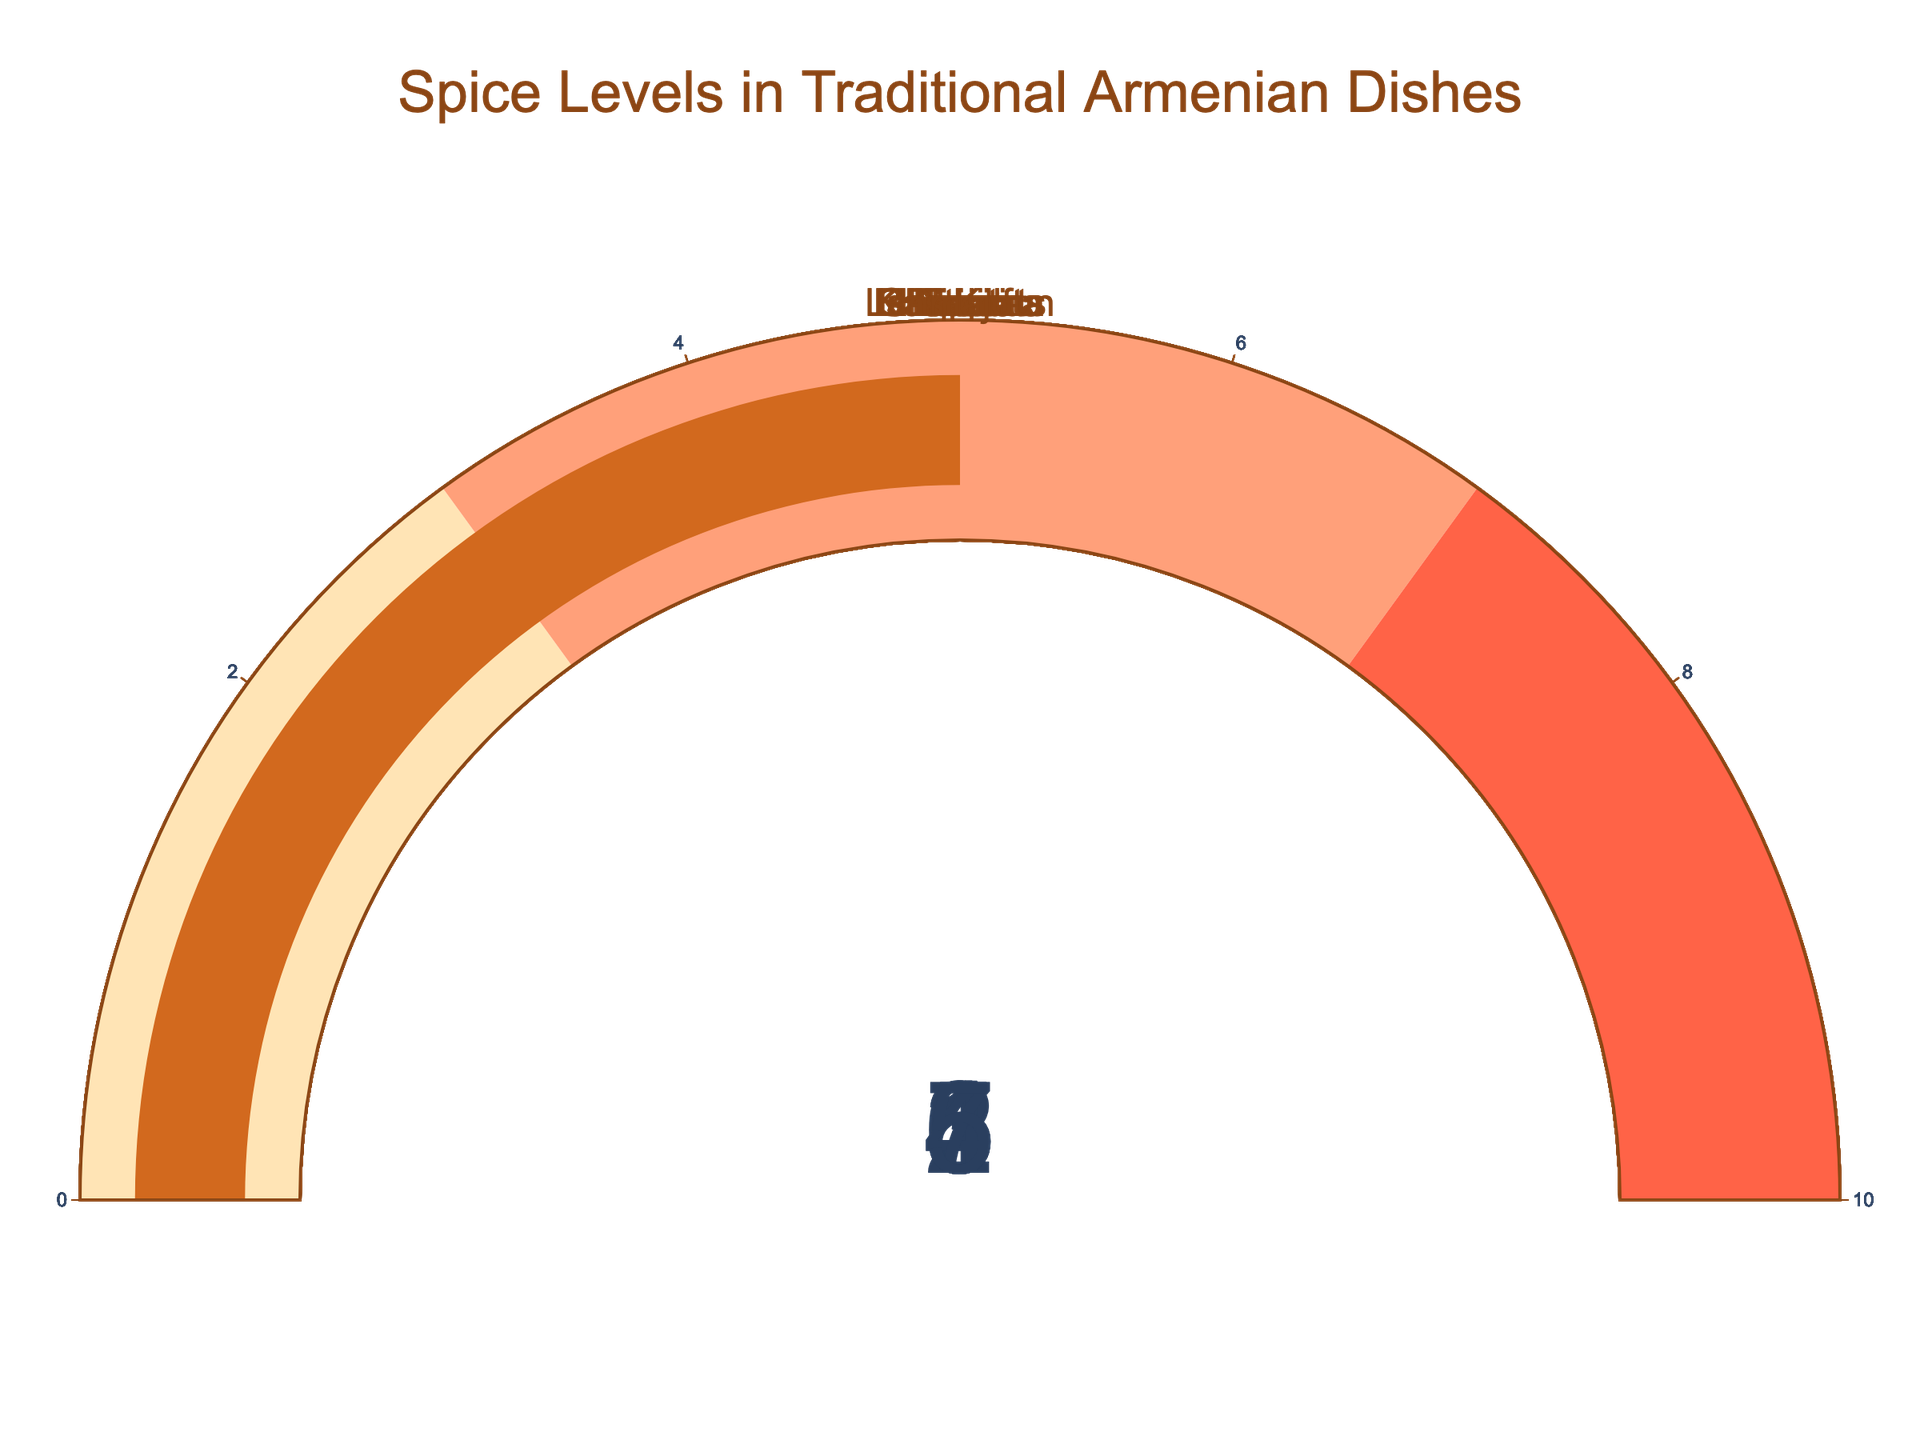What is the title of the figure? The title is usually displayed prominently at the top of the figure. Look at the top of the figure to find the exact wording of the title.
Answer: Spice Levels in Traditional Armenian Dishes Which dish has the highest spice level? Review the values displayed in each gauge, and identify the one with the highest number.
Answer: Basturma How many dishes have a spice level of 4? Look for all the gauges displaying the number 4. Count the total number of such dishes.
Answer: Two dishes What is the average spice level of the dishes shown? Add all the spice level values together (2 + 4 + 5 + 3 + 6 + 1 + 3 + 4 + 7 + 5) and then divide by the number of dishes (10). (2 + 4 + 5 + 3 + 6 + 1 + 3 + 4 + 7 + 5) / 10 = 4
Answer: 4 What is the spice level of Dolma? Look for the gauge labeled 'Dolma' and note the value displayed.
Answer: 3 Which dishes have a spice level below 3? Identify the dishes with gauge values less than 3. Those dishes are Ghapama (2) and Khash (1).
Answer: Ghapama and Khash Compare the spice levels of Khorovats and Lahmajoun. Which one is higher? Check the spice levels for both Khorovats and Lahmajoun. Khorovats is 5 and Lahmajoun is also 5, so they are equal.
Answer: Equal Which range of spice levels is the most frequent among the dishes? Group the dishes by their spice levels (0-3, 3-7, and 7-10), then count the number of dishes in each group. The most frequent range is 3-7 which includes six dishes (Harissa, Khorovats, Ishli Kufta, Dolma, Manti, Lahmajoun).
Answer: 3-7 What is the difference in spice levels between Tjvjik and Khash? Find the spice levels of Tjvjik and Khash, then calculate the difference. Tjvjik is 6 and Khash is 1, so the difference is 6 - 1 = 5.
Answer: 5 